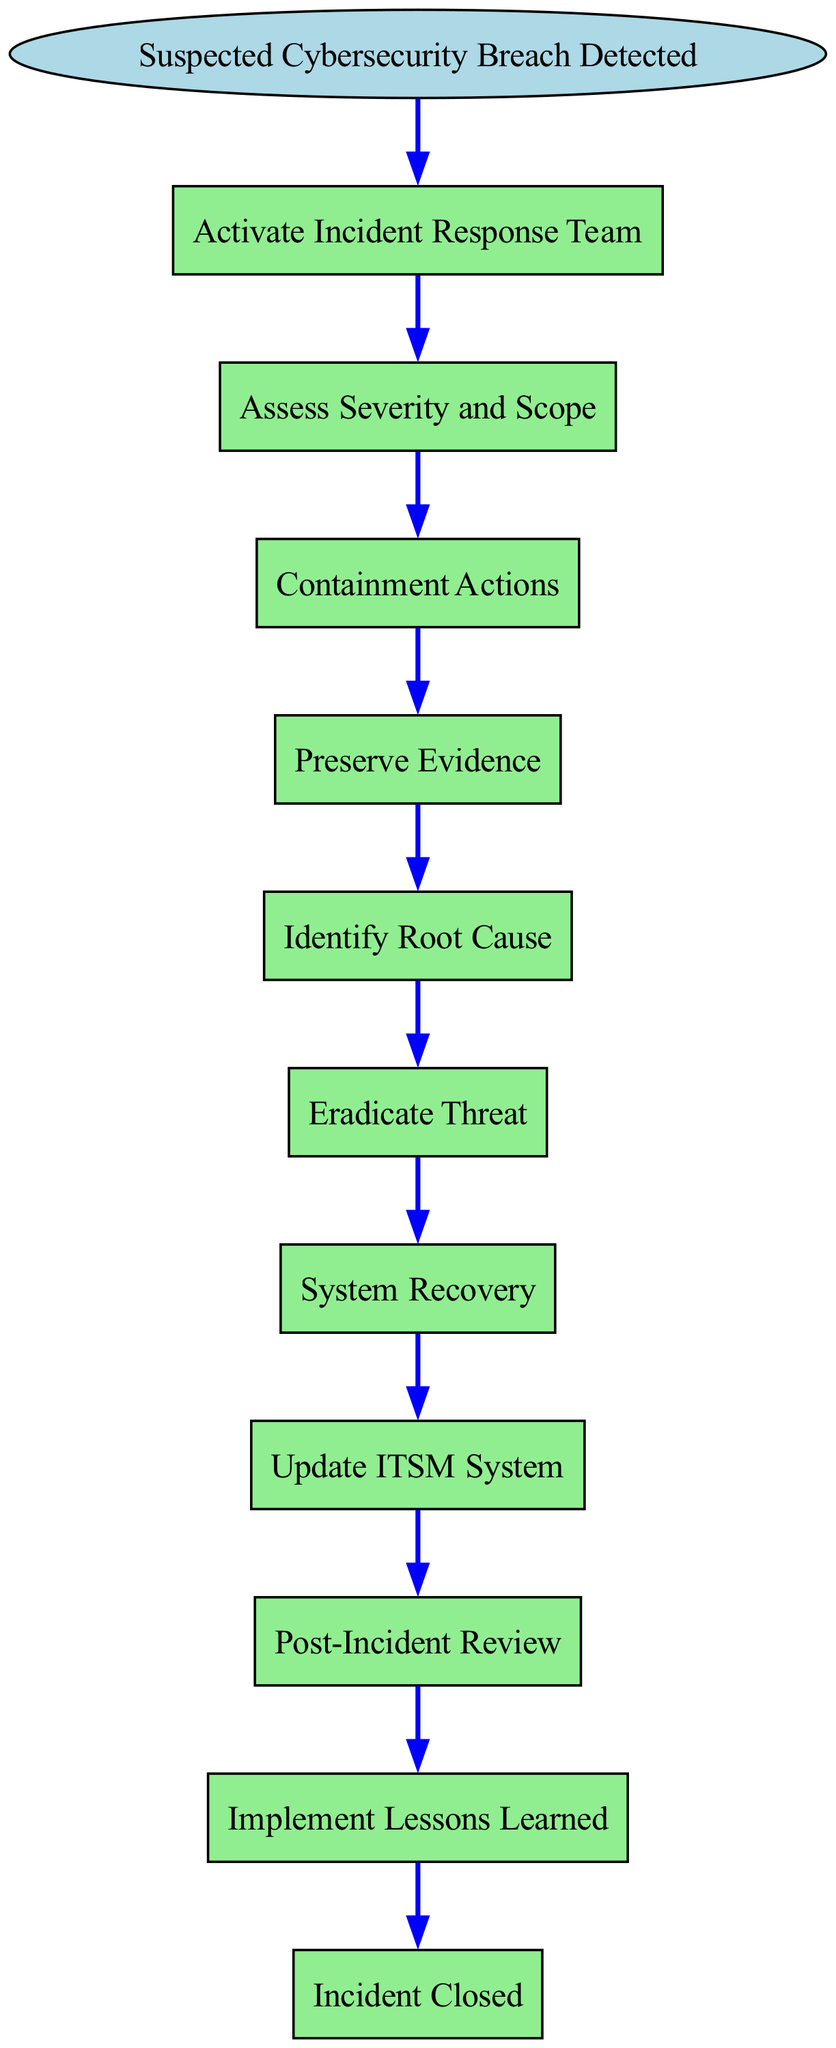What is the first step in the incident response procedure? The diagram starts with the event "Suspected Cybersecurity Breach Detected," which immediately leads to the first action in the process.
Answer: Activate Incident Response Team How many steps are outlined in the incident response procedure? The diagram lists nine steps (from Activate Incident Response Team to Implement Lessons Learned) in the procedure, excluding the start and end nodes.
Answer: Nine What action follows "Identify Root Cause"? The flow shows that after identifying the root cause, the next step is eradication of the threat. The connection can be traced through the steps leading from one to the next.
Answer: Eradicate Threat What is the final action before closing the incident? According to the flow, after all assessment and evidence collection, the last action before the incident is closed is to implement lessons learned. This can be verified by checking the sequence of actions leading to the end.
Answer: Implement Lessons Learned Which step involves preserving evidence? The diagram explicitly states that preserving evidence is a distinct step in the procedure, following containment actions. This information can be directly read from the sequence of steps presented.
Answer: Preserve Evidence What step is initiated after containment actions? The flow indicates that the next logical step after containment actions is preserving evidence. By following the sequence, one can confirm these actions are ordered directly.
Answer: Preserve Evidence In which step is the severity and scope of the incident assessed? The diagram clearly labels the second step as "Assess Severity and Scope," which indicates that it follows the initial activation of the response team.
Answer: Assess Severity and Scope How does the process conclude? The flow chart shows that the final state of the incident response procedure is marked by the "Incident Closed" end node. This termination is clearly indicated after all previous actions are completed.
Answer: Incident Closed What is the transition from "System Recovery" to the next step? The process proceeds from "System Recovery" directly to updating the IT Service Management system, illustrating a straightforward transition from recovery to documentation.
Answer: Update ITSM System 